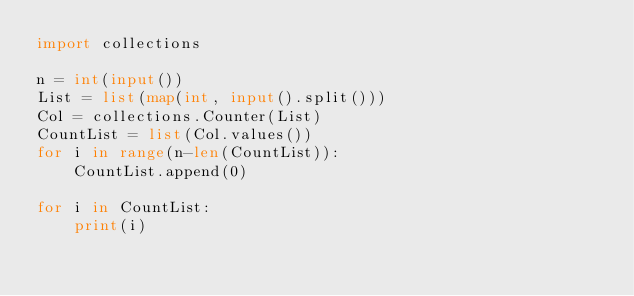Convert code to text. <code><loc_0><loc_0><loc_500><loc_500><_Python_>import collections

n = int(input())
List = list(map(int, input().split()))
Col = collections.Counter(List)
CountList = list(Col.values()) 
for i in range(n-len(CountList)):
    CountList.append(0)

for i in CountList:
    print(i)

</code> 